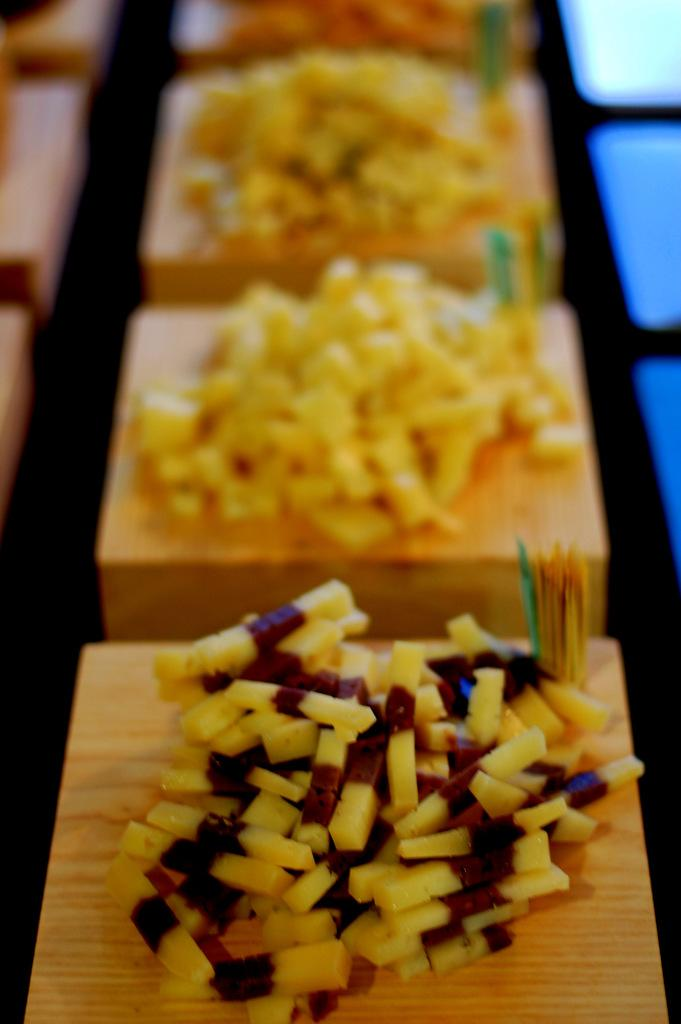What color are the objects in the image that are holding food? The objects in the image that are holding food are cream-colored. What types of food can be seen on the cream-colored objects? There are different types of food on the cream-colored objects. How would you describe the quality of the image in the background? The image is blurry in the background. What type of stone can be seen in the image? There is no stone present in the image. How many planes are visible in the image? There are no planes visible in the image. 